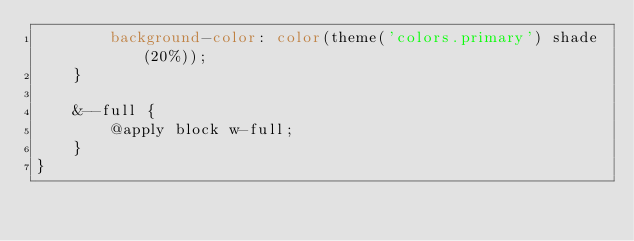<code> <loc_0><loc_0><loc_500><loc_500><_CSS_>        background-color: color(theme('colors.primary') shade(20%));
    }

    &--full {
        @apply block w-full;
    }
}</code> 